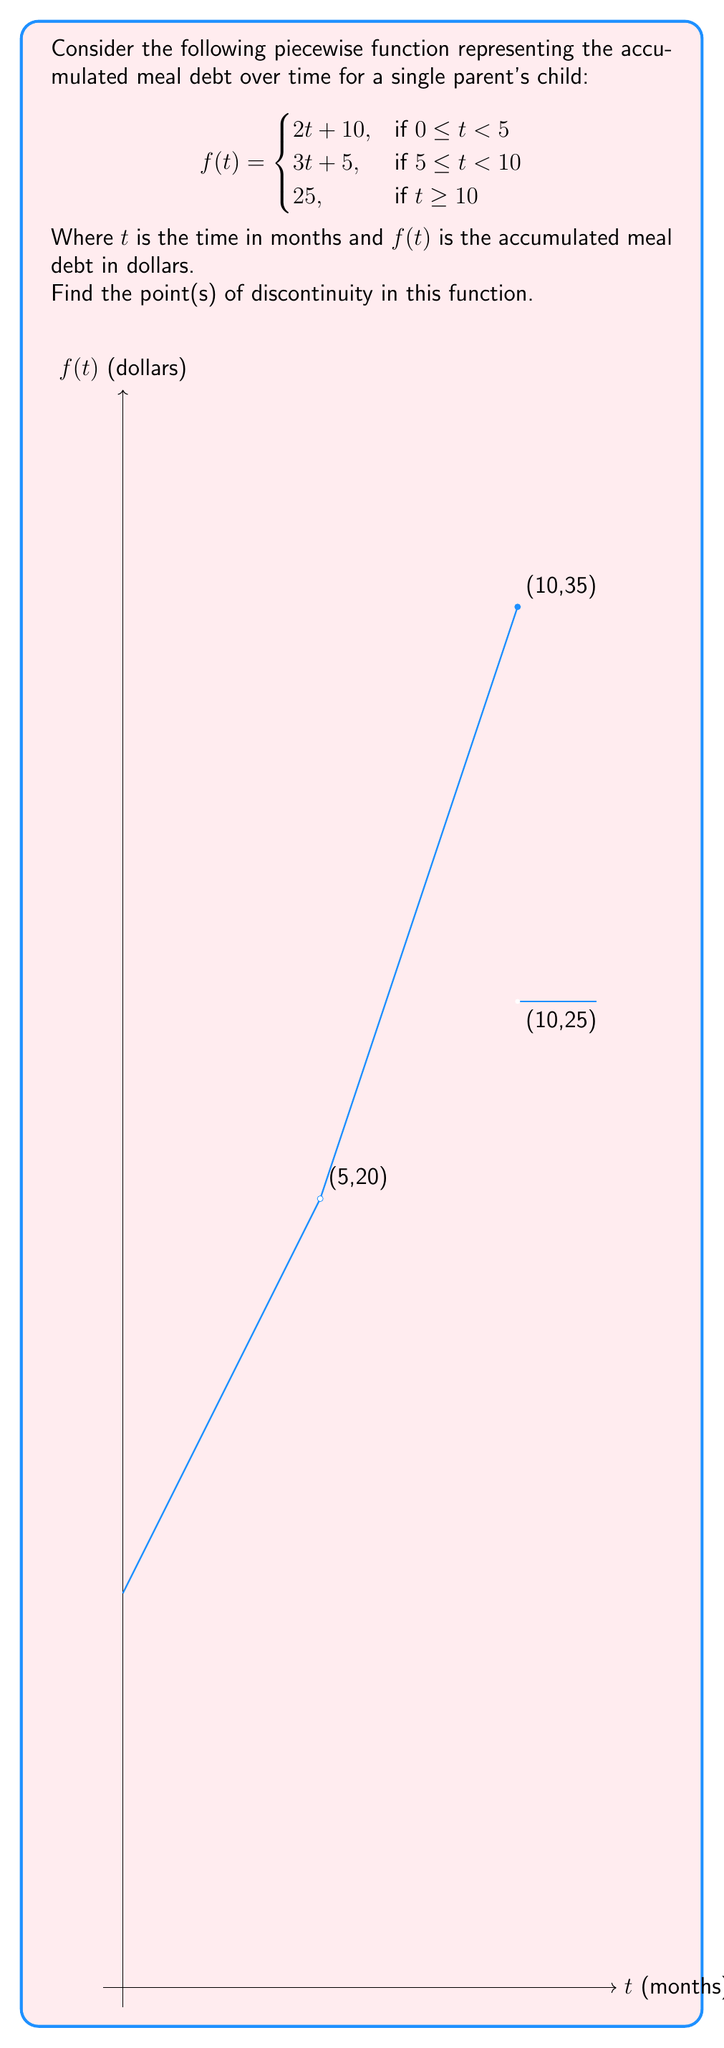Can you solve this math problem? To find the points of discontinuity, we need to examine where the function is not continuous. A function is continuous at a point if:
1. The function is defined at that point
2. The limit of the function exists as we approach the point from both sides
3. The limit equals the function value at that point

Let's check the potential points of discontinuity:

1. At $t = 5$:
   Left limit: $\lim_{t \to 5^-} f(t) = \lim_{t \to 5^-} (2t + 10) = 20$
   Right limit: $\lim_{t \to 5^+} f(t) = \lim_{t \to 5^+} (3t + 5) = 20$
   Function value: $f(5) = 3(5) + 5 = 20$
   
   All three conditions are met, so the function is continuous at $t = 5$.

2. At $t = 10$:
   Left limit: $\lim_{t \to 10^-} f(t) = \lim_{t \to 10^-} (3t + 5) = 35$
   Right limit: $\lim_{t \to 10^+} f(t) = 25$
   Function value: $f(10) = 25$
   
   The left limit does not equal the right limit or the function value, so there is a discontinuity at $t = 10$.

Therefore, the function has a point of discontinuity at $t = 10$.
Answer: $t = 10$ 